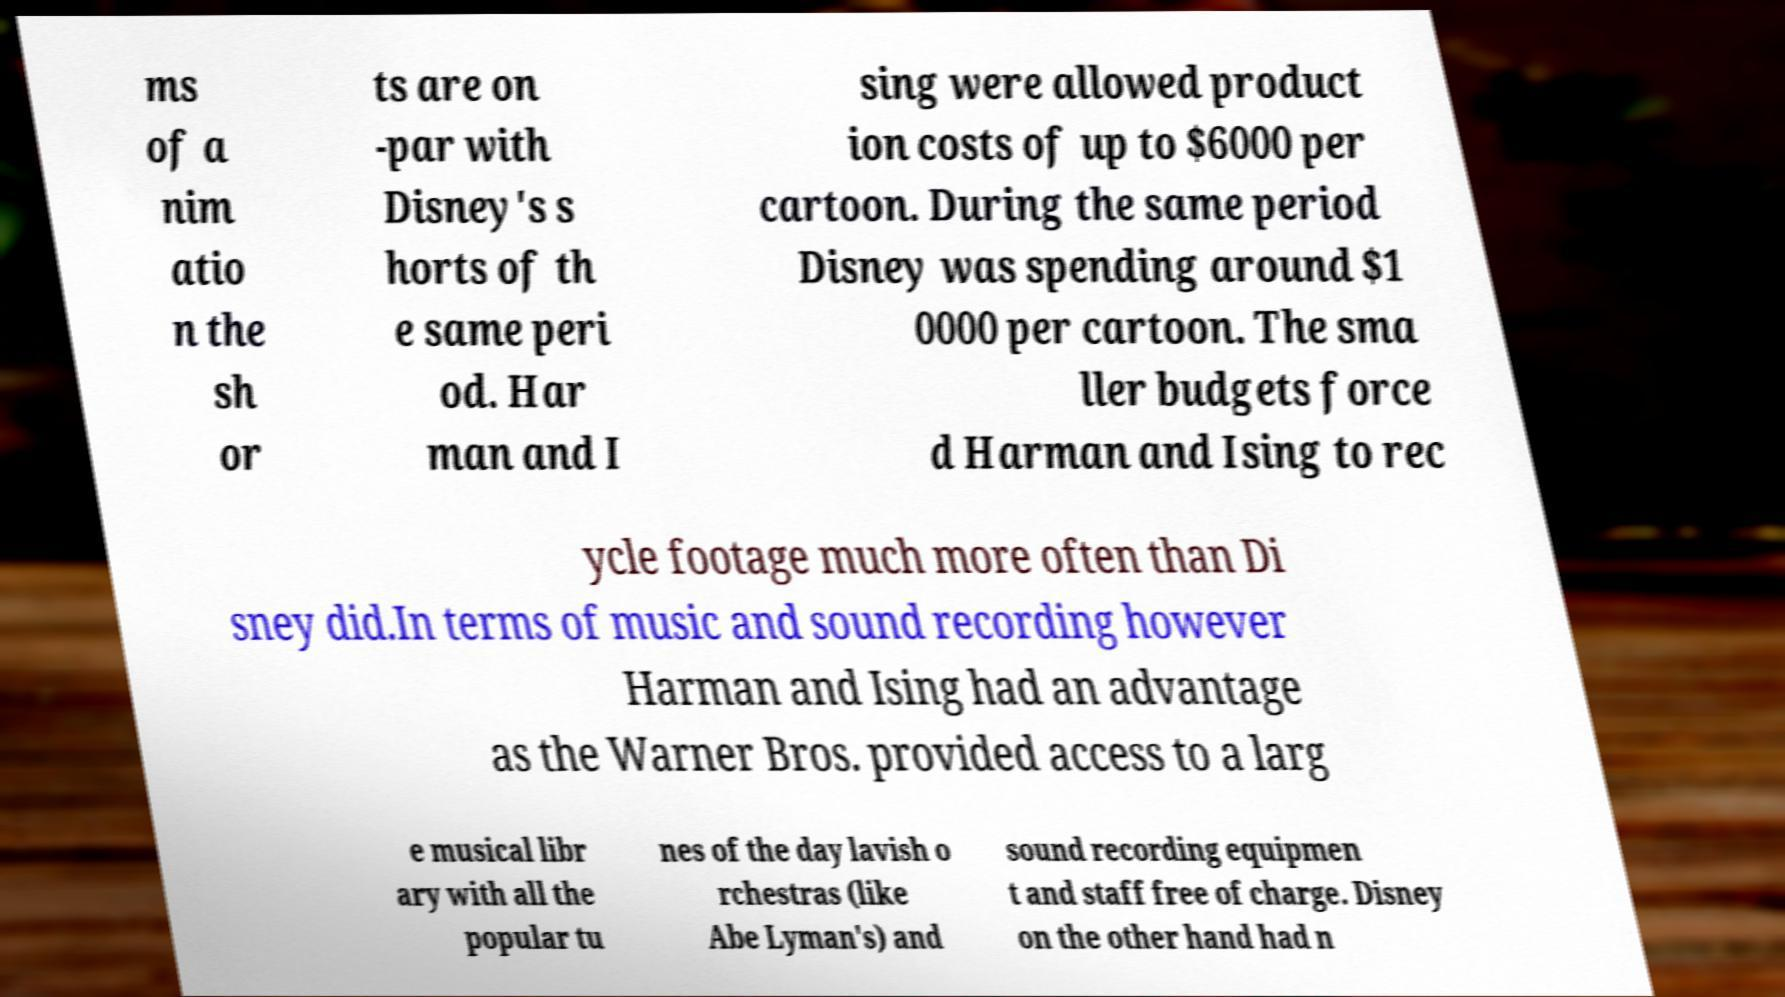Can you accurately transcribe the text from the provided image for me? ms of a nim atio n the sh or ts are on -par with Disney's s horts of th e same peri od. Har man and I sing were allowed product ion costs of up to $6000 per cartoon. During the same period Disney was spending around $1 0000 per cartoon. The sma ller budgets force d Harman and Ising to rec ycle footage much more often than Di sney did.In terms of music and sound recording however Harman and Ising had an advantage as the Warner Bros. provided access to a larg e musical libr ary with all the popular tu nes of the day lavish o rchestras (like Abe Lyman's) and sound recording equipmen t and staff free of charge. Disney on the other hand had n 